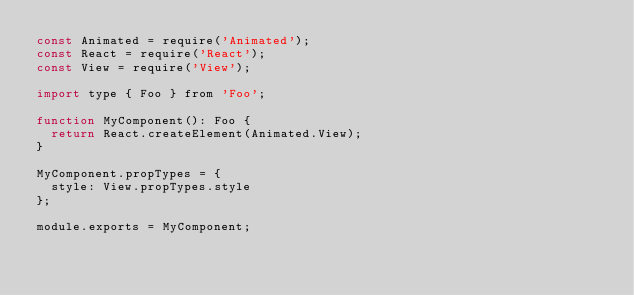<code> <loc_0><loc_0><loc_500><loc_500><_JavaScript_>const Animated = require('Animated');
const React = require('React');
const View = require('View');

import type { Foo } from 'Foo';

function MyComponent(): Foo {
  return React.createElement(Animated.View);
}

MyComponent.propTypes = {
  style: View.propTypes.style
};

module.exports = MyComponent;
</code> 